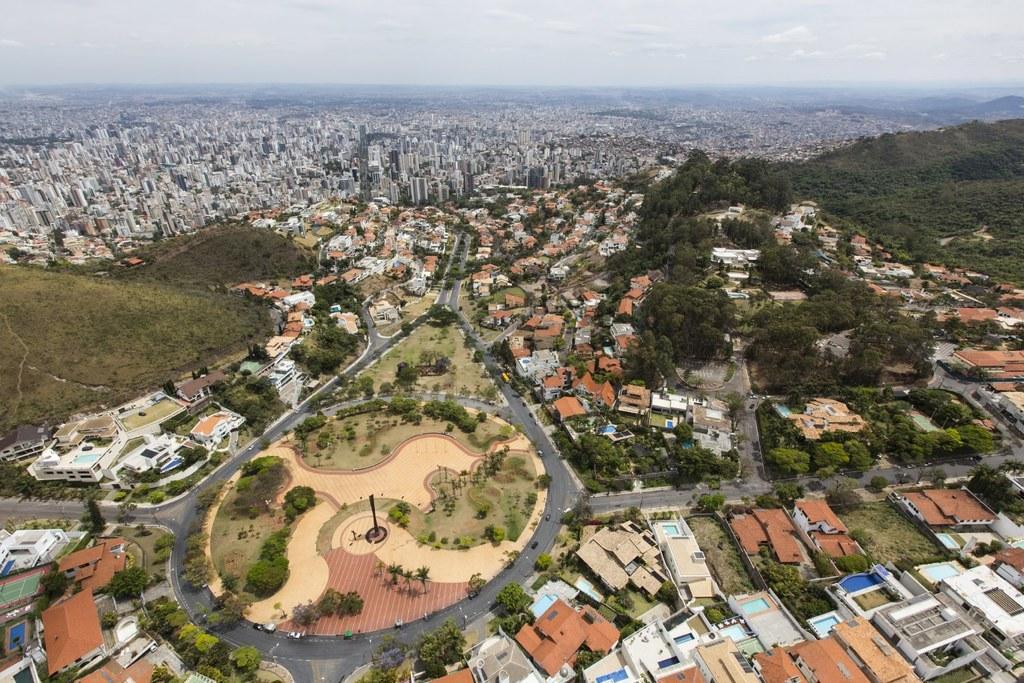In one or two sentences, can you explain what this image depicts? In this image I see number of buildings and I see the road on which there are few vehicles and I see the trees and I see the sky in the background. 